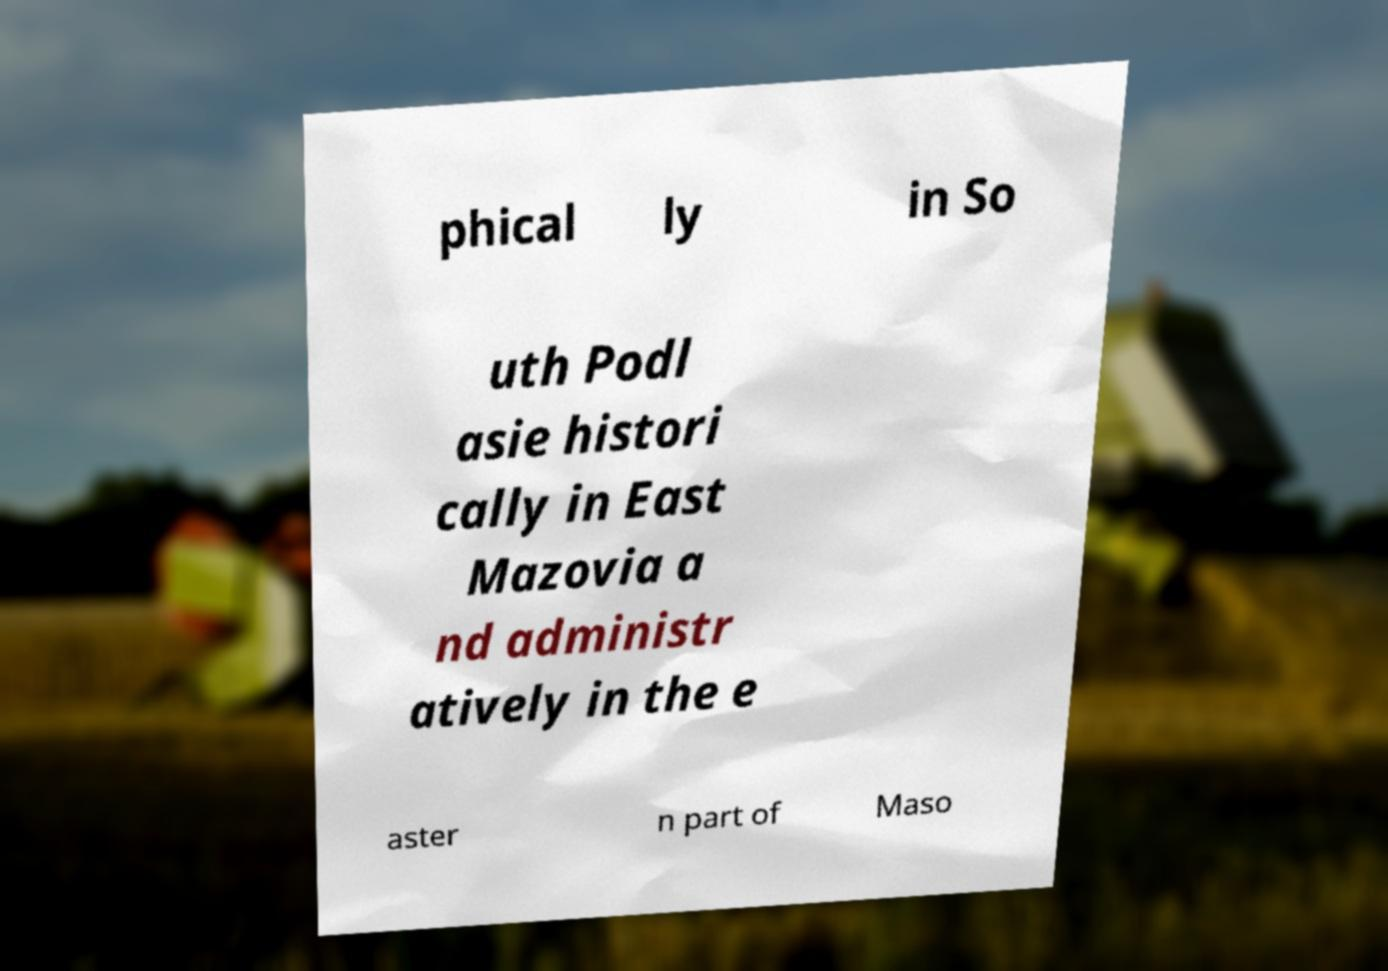Please identify and transcribe the text found in this image. phical ly in So uth Podl asie histori cally in East Mazovia a nd administr atively in the e aster n part of Maso 